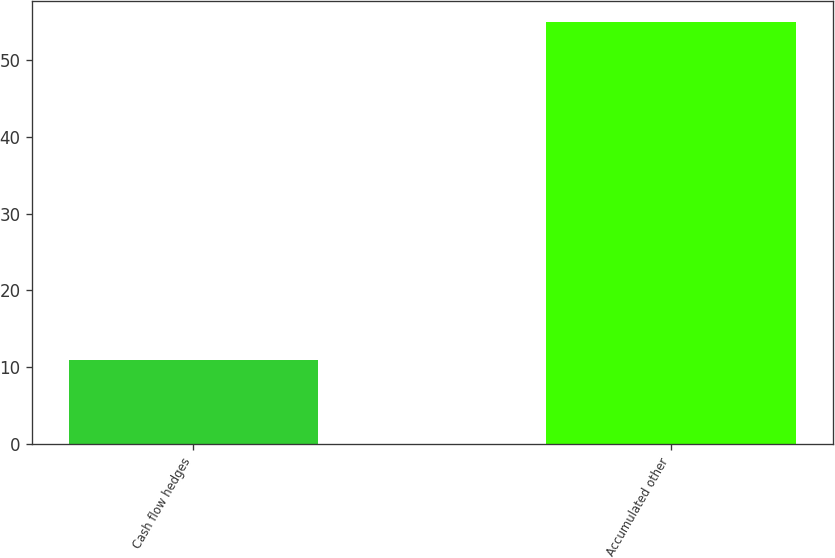Convert chart. <chart><loc_0><loc_0><loc_500><loc_500><bar_chart><fcel>Cash flow hedges<fcel>Accumulated other<nl><fcel>11<fcel>55<nl></chart> 